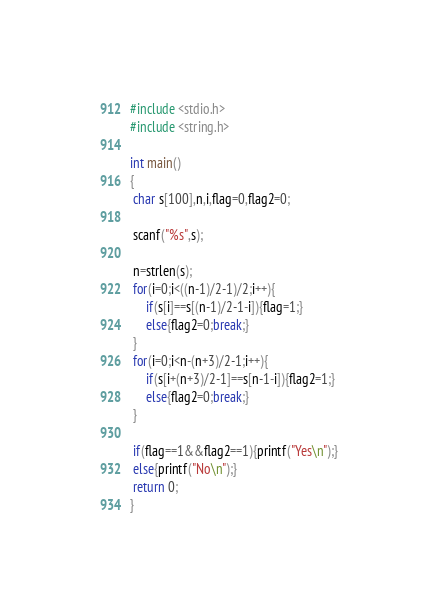Convert code to text. <code><loc_0><loc_0><loc_500><loc_500><_C_>#include <stdio.h>
#include <string.h>
 
int main()
{
 char s[100],n,i,flag=0,flag2=0;
 
 scanf("%s",s);
 
 n=strlen(s);
 for(i=0;i<((n-1)/2-1)/2;i++){
     if(s[i]==s[(n-1)/2-1-i]){flag=1;}
     else{flag2=0;break;}
 }
 for(i=0;i<n-(n+3)/2-1;i++){
     if(s[i+(n+3)/2-1]==s[n-1-i]){flag2=1;}
     else{flag2=0;break;}
 }

 if(flag==1&&flag2==1){printf("Yes\n");}
 else{printf("No\n");}
 return 0;
}</code> 